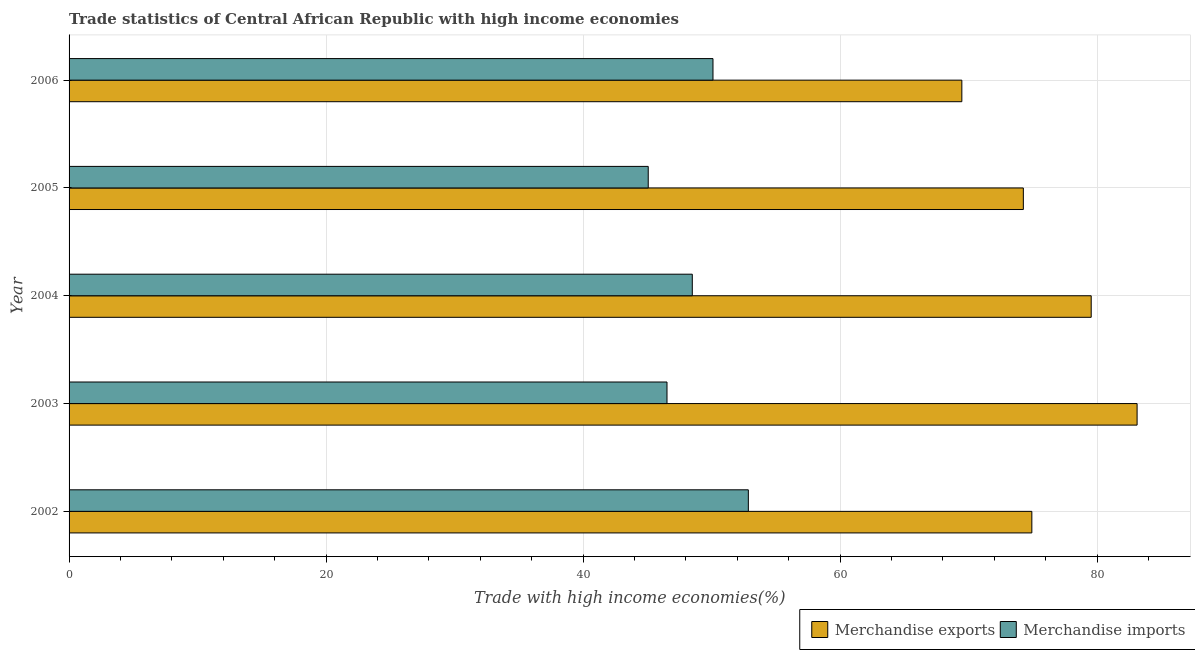How many groups of bars are there?
Provide a succinct answer. 5. Are the number of bars per tick equal to the number of legend labels?
Provide a succinct answer. Yes. How many bars are there on the 2nd tick from the bottom?
Your answer should be very brief. 2. What is the label of the 5th group of bars from the top?
Provide a short and direct response. 2002. What is the merchandise imports in 2006?
Keep it short and to the point. 50.11. Across all years, what is the maximum merchandise exports?
Keep it short and to the point. 83.11. Across all years, what is the minimum merchandise exports?
Your answer should be very brief. 69.47. What is the total merchandise imports in the graph?
Your answer should be very brief. 243.06. What is the difference between the merchandise imports in 2002 and that in 2004?
Provide a succinct answer. 4.36. What is the difference between the merchandise exports in 2002 and the merchandise imports in 2005?
Ensure brevity in your answer.  29.85. What is the average merchandise exports per year?
Provide a succinct answer. 76.26. In the year 2006, what is the difference between the merchandise imports and merchandise exports?
Give a very brief answer. -19.36. In how many years, is the merchandise imports greater than 68 %?
Offer a terse response. 0. What is the ratio of the merchandise exports in 2002 to that in 2006?
Your answer should be compact. 1.08. Is the merchandise exports in 2003 less than that in 2004?
Give a very brief answer. No. What is the difference between the highest and the second highest merchandise imports?
Ensure brevity in your answer.  2.75. What is the difference between the highest and the lowest merchandise imports?
Your answer should be compact. 7.79. In how many years, is the merchandise imports greater than the average merchandise imports taken over all years?
Offer a terse response. 2. How many bars are there?
Keep it short and to the point. 10. Are the values on the major ticks of X-axis written in scientific E-notation?
Provide a succinct answer. No. Does the graph contain any zero values?
Provide a short and direct response. No. Does the graph contain grids?
Offer a very short reply. Yes. How many legend labels are there?
Provide a succinct answer. 2. How are the legend labels stacked?
Make the answer very short. Horizontal. What is the title of the graph?
Offer a terse response. Trade statistics of Central African Republic with high income economies. What is the label or title of the X-axis?
Provide a short and direct response. Trade with high income economies(%). What is the Trade with high income economies(%) in Merchandise exports in 2002?
Make the answer very short. 74.92. What is the Trade with high income economies(%) in Merchandise imports in 2002?
Keep it short and to the point. 52.86. What is the Trade with high income economies(%) of Merchandise exports in 2003?
Your answer should be compact. 83.11. What is the Trade with high income economies(%) of Merchandise imports in 2003?
Offer a very short reply. 46.53. What is the Trade with high income economies(%) of Merchandise exports in 2004?
Provide a succinct answer. 79.54. What is the Trade with high income economies(%) of Merchandise imports in 2004?
Ensure brevity in your answer.  48.5. What is the Trade with high income economies(%) in Merchandise exports in 2005?
Provide a short and direct response. 74.26. What is the Trade with high income economies(%) in Merchandise imports in 2005?
Make the answer very short. 45.07. What is the Trade with high income economies(%) in Merchandise exports in 2006?
Make the answer very short. 69.47. What is the Trade with high income economies(%) in Merchandise imports in 2006?
Your answer should be compact. 50.11. Across all years, what is the maximum Trade with high income economies(%) of Merchandise exports?
Keep it short and to the point. 83.11. Across all years, what is the maximum Trade with high income economies(%) in Merchandise imports?
Your answer should be compact. 52.86. Across all years, what is the minimum Trade with high income economies(%) of Merchandise exports?
Make the answer very short. 69.47. Across all years, what is the minimum Trade with high income economies(%) in Merchandise imports?
Your answer should be compact. 45.07. What is the total Trade with high income economies(%) of Merchandise exports in the graph?
Provide a short and direct response. 381.3. What is the total Trade with high income economies(%) in Merchandise imports in the graph?
Your answer should be compact. 243.06. What is the difference between the Trade with high income economies(%) of Merchandise exports in 2002 and that in 2003?
Ensure brevity in your answer.  -8.19. What is the difference between the Trade with high income economies(%) in Merchandise imports in 2002 and that in 2003?
Your answer should be compact. 6.33. What is the difference between the Trade with high income economies(%) in Merchandise exports in 2002 and that in 2004?
Your answer should be very brief. -4.62. What is the difference between the Trade with high income economies(%) in Merchandise imports in 2002 and that in 2004?
Offer a very short reply. 4.36. What is the difference between the Trade with high income economies(%) of Merchandise exports in 2002 and that in 2005?
Offer a terse response. 0.66. What is the difference between the Trade with high income economies(%) of Merchandise imports in 2002 and that in 2005?
Provide a succinct answer. 7.79. What is the difference between the Trade with high income economies(%) in Merchandise exports in 2002 and that in 2006?
Provide a short and direct response. 5.45. What is the difference between the Trade with high income economies(%) of Merchandise imports in 2002 and that in 2006?
Make the answer very short. 2.75. What is the difference between the Trade with high income economies(%) of Merchandise exports in 2003 and that in 2004?
Offer a terse response. 3.57. What is the difference between the Trade with high income economies(%) in Merchandise imports in 2003 and that in 2004?
Your answer should be compact. -1.97. What is the difference between the Trade with high income economies(%) in Merchandise exports in 2003 and that in 2005?
Provide a succinct answer. 8.85. What is the difference between the Trade with high income economies(%) of Merchandise imports in 2003 and that in 2005?
Keep it short and to the point. 1.46. What is the difference between the Trade with high income economies(%) in Merchandise exports in 2003 and that in 2006?
Give a very brief answer. 13.64. What is the difference between the Trade with high income economies(%) of Merchandise imports in 2003 and that in 2006?
Offer a very short reply. -3.58. What is the difference between the Trade with high income economies(%) in Merchandise exports in 2004 and that in 2005?
Keep it short and to the point. 5.28. What is the difference between the Trade with high income economies(%) of Merchandise imports in 2004 and that in 2005?
Keep it short and to the point. 3.43. What is the difference between the Trade with high income economies(%) of Merchandise exports in 2004 and that in 2006?
Provide a succinct answer. 10.07. What is the difference between the Trade with high income economies(%) in Merchandise imports in 2004 and that in 2006?
Provide a succinct answer. -1.61. What is the difference between the Trade with high income economies(%) of Merchandise exports in 2005 and that in 2006?
Your answer should be very brief. 4.79. What is the difference between the Trade with high income economies(%) of Merchandise imports in 2005 and that in 2006?
Make the answer very short. -5.04. What is the difference between the Trade with high income economies(%) in Merchandise exports in 2002 and the Trade with high income economies(%) in Merchandise imports in 2003?
Ensure brevity in your answer.  28.39. What is the difference between the Trade with high income economies(%) of Merchandise exports in 2002 and the Trade with high income economies(%) of Merchandise imports in 2004?
Provide a succinct answer. 26.42. What is the difference between the Trade with high income economies(%) of Merchandise exports in 2002 and the Trade with high income economies(%) of Merchandise imports in 2005?
Your answer should be very brief. 29.85. What is the difference between the Trade with high income economies(%) of Merchandise exports in 2002 and the Trade with high income economies(%) of Merchandise imports in 2006?
Your answer should be compact. 24.81. What is the difference between the Trade with high income economies(%) of Merchandise exports in 2003 and the Trade with high income economies(%) of Merchandise imports in 2004?
Make the answer very short. 34.61. What is the difference between the Trade with high income economies(%) in Merchandise exports in 2003 and the Trade with high income economies(%) in Merchandise imports in 2005?
Offer a terse response. 38.04. What is the difference between the Trade with high income economies(%) of Merchandise exports in 2003 and the Trade with high income economies(%) of Merchandise imports in 2006?
Your response must be concise. 33. What is the difference between the Trade with high income economies(%) in Merchandise exports in 2004 and the Trade with high income economies(%) in Merchandise imports in 2005?
Your answer should be compact. 34.47. What is the difference between the Trade with high income economies(%) in Merchandise exports in 2004 and the Trade with high income economies(%) in Merchandise imports in 2006?
Keep it short and to the point. 29.43. What is the difference between the Trade with high income economies(%) of Merchandise exports in 2005 and the Trade with high income economies(%) of Merchandise imports in 2006?
Provide a succinct answer. 24.15. What is the average Trade with high income economies(%) of Merchandise exports per year?
Your response must be concise. 76.26. What is the average Trade with high income economies(%) in Merchandise imports per year?
Provide a short and direct response. 48.61. In the year 2002, what is the difference between the Trade with high income economies(%) in Merchandise exports and Trade with high income economies(%) in Merchandise imports?
Offer a terse response. 22.06. In the year 2003, what is the difference between the Trade with high income economies(%) of Merchandise exports and Trade with high income economies(%) of Merchandise imports?
Provide a succinct answer. 36.58. In the year 2004, what is the difference between the Trade with high income economies(%) in Merchandise exports and Trade with high income economies(%) in Merchandise imports?
Keep it short and to the point. 31.04. In the year 2005, what is the difference between the Trade with high income economies(%) in Merchandise exports and Trade with high income economies(%) in Merchandise imports?
Provide a succinct answer. 29.19. In the year 2006, what is the difference between the Trade with high income economies(%) of Merchandise exports and Trade with high income economies(%) of Merchandise imports?
Give a very brief answer. 19.36. What is the ratio of the Trade with high income economies(%) of Merchandise exports in 2002 to that in 2003?
Keep it short and to the point. 0.9. What is the ratio of the Trade with high income economies(%) in Merchandise imports in 2002 to that in 2003?
Your answer should be very brief. 1.14. What is the ratio of the Trade with high income economies(%) in Merchandise exports in 2002 to that in 2004?
Your answer should be very brief. 0.94. What is the ratio of the Trade with high income economies(%) of Merchandise imports in 2002 to that in 2004?
Keep it short and to the point. 1.09. What is the ratio of the Trade with high income economies(%) of Merchandise exports in 2002 to that in 2005?
Your answer should be compact. 1.01. What is the ratio of the Trade with high income economies(%) of Merchandise imports in 2002 to that in 2005?
Provide a succinct answer. 1.17. What is the ratio of the Trade with high income economies(%) of Merchandise exports in 2002 to that in 2006?
Ensure brevity in your answer.  1.08. What is the ratio of the Trade with high income economies(%) of Merchandise imports in 2002 to that in 2006?
Give a very brief answer. 1.05. What is the ratio of the Trade with high income economies(%) of Merchandise exports in 2003 to that in 2004?
Keep it short and to the point. 1.04. What is the ratio of the Trade with high income economies(%) in Merchandise imports in 2003 to that in 2004?
Make the answer very short. 0.96. What is the ratio of the Trade with high income economies(%) of Merchandise exports in 2003 to that in 2005?
Make the answer very short. 1.12. What is the ratio of the Trade with high income economies(%) of Merchandise imports in 2003 to that in 2005?
Keep it short and to the point. 1.03. What is the ratio of the Trade with high income economies(%) of Merchandise exports in 2003 to that in 2006?
Ensure brevity in your answer.  1.2. What is the ratio of the Trade with high income economies(%) of Merchandise exports in 2004 to that in 2005?
Your answer should be very brief. 1.07. What is the ratio of the Trade with high income economies(%) of Merchandise imports in 2004 to that in 2005?
Your answer should be compact. 1.08. What is the ratio of the Trade with high income economies(%) of Merchandise exports in 2004 to that in 2006?
Offer a terse response. 1.14. What is the ratio of the Trade with high income economies(%) in Merchandise imports in 2004 to that in 2006?
Offer a very short reply. 0.97. What is the ratio of the Trade with high income economies(%) in Merchandise exports in 2005 to that in 2006?
Your response must be concise. 1.07. What is the ratio of the Trade with high income economies(%) in Merchandise imports in 2005 to that in 2006?
Your answer should be very brief. 0.9. What is the difference between the highest and the second highest Trade with high income economies(%) of Merchandise exports?
Make the answer very short. 3.57. What is the difference between the highest and the second highest Trade with high income economies(%) in Merchandise imports?
Ensure brevity in your answer.  2.75. What is the difference between the highest and the lowest Trade with high income economies(%) of Merchandise exports?
Your answer should be compact. 13.64. What is the difference between the highest and the lowest Trade with high income economies(%) of Merchandise imports?
Provide a succinct answer. 7.79. 